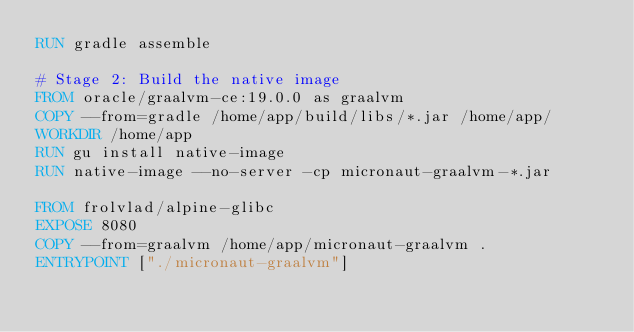Convert code to text. <code><loc_0><loc_0><loc_500><loc_500><_Dockerfile_>RUN gradle assemble

# Stage 2: Build the native image
FROM oracle/graalvm-ce:19.0.0 as graalvm
COPY --from=gradle /home/app/build/libs/*.jar /home/app/
WORKDIR /home/app
RUN gu install native-image
RUN native-image --no-server -cp micronaut-graalvm-*.jar

FROM frolvlad/alpine-glibc
EXPOSE 8080
COPY --from=graalvm /home/app/micronaut-graalvm .
ENTRYPOINT ["./micronaut-graalvm"]</code> 